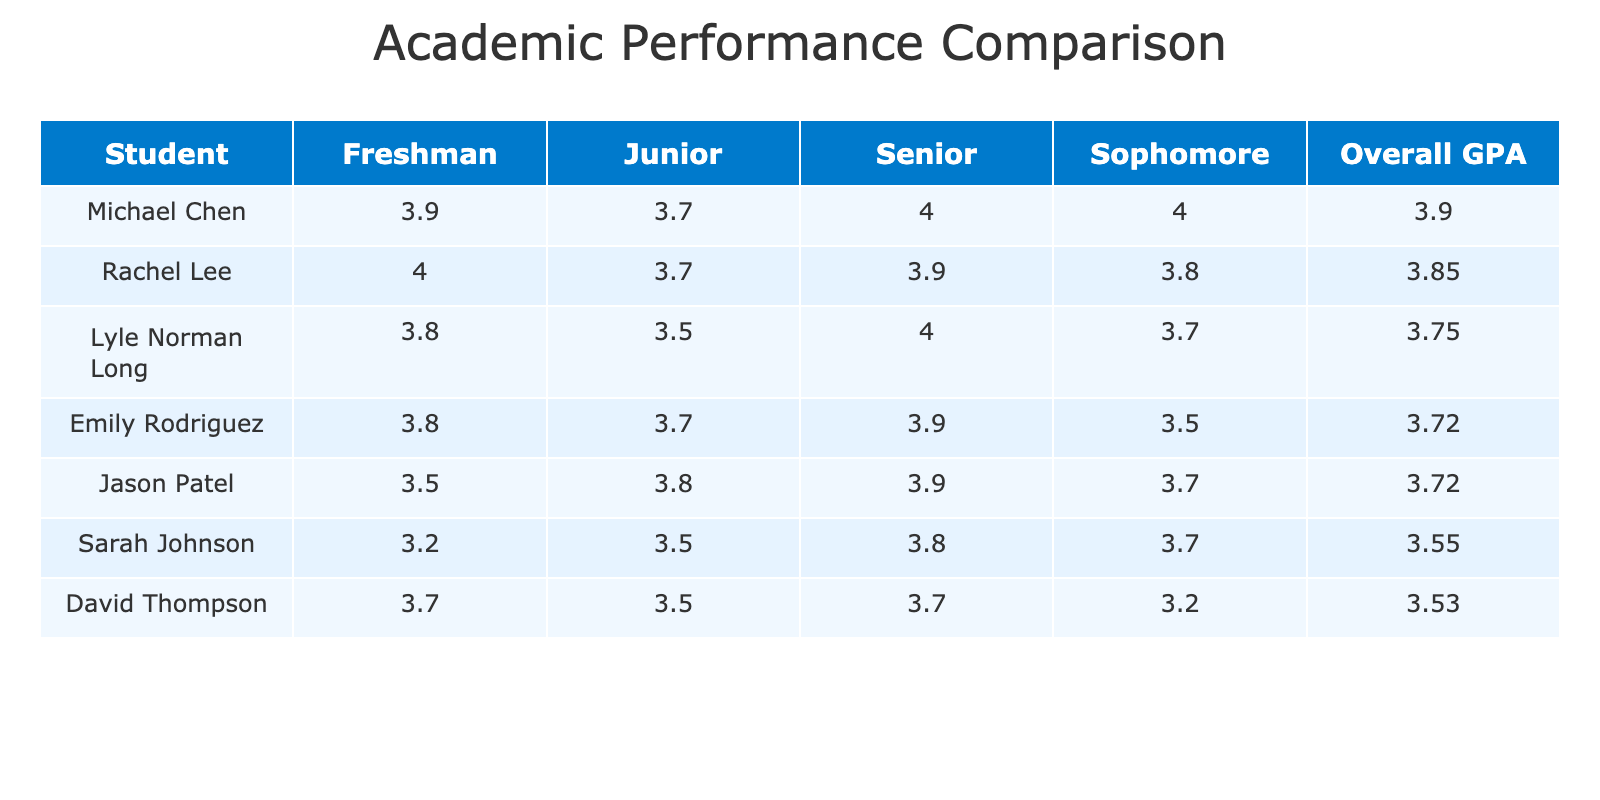What is the highest GPA achieved by a student in their senior year? The highest GPA in the senior year can be identified by looking through the "Senior" column for each student. Michael Chen, Lyle Norman Long, and Rachel Lee all received an A+, which corresponds to a GPA of 4.0, while others had lower GPAs. Thus, the highest GPA is 4.0.
Answer: 4.0 Which student had the overall highest GPA throughout their high school years? To determine the overall highest GPA, we can look at the "Overall GPA" column. By examining the values, Michael Chen has the highest overall GPA at 4.0. This is a comparison across all students.
Answer: 4.0 Did any student consistently achieve a GPA of 3.8 or above in all four years? We need to check each student's GPA across all four years. Lyle Norman Long and Michael Chen had GPAs of 3.8 or higher in each year: Lyle had grades of A, A-, B+, and A+, and Michael had A, A, A-, and A+. Thus, they do not consistently have 3.8 or above in all years.
Answer: No What is the average GPA for Rachel Lee across her four years? Rachel Lee's GPAs for each year are A+ (4.0), A (3.8), A- (3.7), and A (3.9). To find the average, we sum these GPAs: (4.0 + 3.8 + 3.7 + 3.9) = 15.4. Then, divide by the number of years (4): 15.4 / 4 = 3.85.
Answer: 3.85 How many students had a GPA of 3.5 or lower in their junior year? To find the number of students with a GPA of 3.5 or lower in the junior year, we need to look at the "Junior" column. The students are Lyle Norman Long (B+, 3.5), David Thompson (B+, 3.5), and Jason Patel (A, 3.8). Only Lyle and David meet the criteria, totaling 2 students.
Answer: 2 How much did Sarah Johnson's GPA improve from her freshman to senior year? Sarah Johnson's GPA in her freshman year was 3.2 and in her senior year was 3.8. The improvement can be calculated as 3.8 - 3.2 = 0.6. Thus, her GPA improved by 0.6.
Answer: 0.6 Which student participated in the most extracurricular activities? Looking at the data, the extracurricular activities for each student are as follows: Lyle Norman Long (Chess Club, Robotics Team, Science Olympiad, Math Club) has four activities. We check the others: Michael Chen (Math Team, Science Club, Robotics Club, Programming Club) also has four. Similarly, Rachel Lee (Orchestra, Drama Club, Film Society, Literary Magazine) has four as well, and no students exceed this number.
Answer: 4 Is there a distinction in GPA trends between boys and girls in the class? We analyze the GPAs of boys (Michael Chen, Jason Patel, David Thompson, Lyle Norman Long) and girls (Sarah Johnson, Rachel Lee, Emily Rodriguez). The average GPA for boys is (3.8 + 4.0 + 3.6 + 3.8) / 4 = 3.78 and for girls it's (3.2 + 3.8 + 3.9 + 3.85) / 4 = 3.73. This shows the boys have a slightly higher average GPA compared to girls, indicating a minor distinction.
Answer: Yes, boys have a higher average GPA 